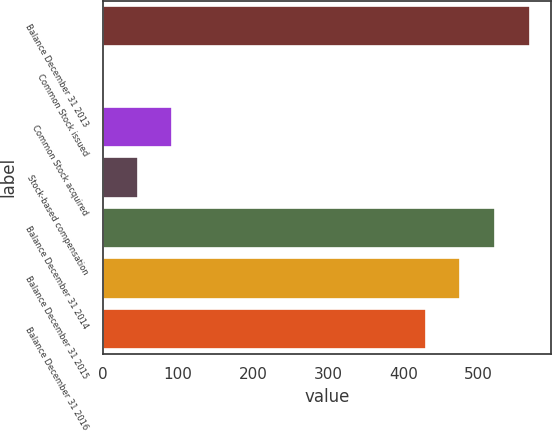Convert chart to OTSL. <chart><loc_0><loc_0><loc_500><loc_500><bar_chart><fcel>Balance December 31 2013<fcel>Common Stock issued<fcel>Common Stock acquired<fcel>Stock-based compensation<fcel>Balance December 31 2014<fcel>Balance December 31 2015<fcel>Balance December 31 2016<nl><fcel>567.84<fcel>0.34<fcel>92.5<fcel>46.42<fcel>521.76<fcel>475.68<fcel>429.6<nl></chart> 